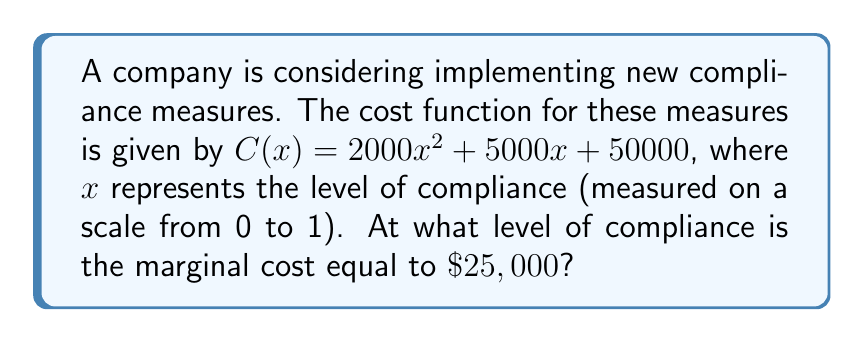Help me with this question. To solve this problem, we need to follow these steps:

1. Recall that the marginal cost is the derivative of the cost function.

2. Calculate the derivative of $C(x)$:
   $$C'(x) = \frac{d}{dx}(2000x^2 + 5000x + 50000)$$
   $$C'(x) = 4000x + 5000$$

3. Set the marginal cost equal to $\$25,000$:
   $$4000x + 5000 = 25000$$

4. Solve for $x$:
   $$4000x = 20000$$
   $$x = \frac{20000}{4000} = 5$$

5. Check if the solution is within the given range (0 to 1):
   Since $x = 5$ is outside the range, we need to consider the endpoints.

6. Evaluate the marginal cost at $x = 1$:
   $$C'(1) = 4000(1) + 5000 = 9000$$

Therefore, the marginal cost never reaches $\$25,000$ within the given range of compliance levels.
Answer: The marginal cost does not reach $\$25,000$ within the valid range of compliance levels (0 to 1). 